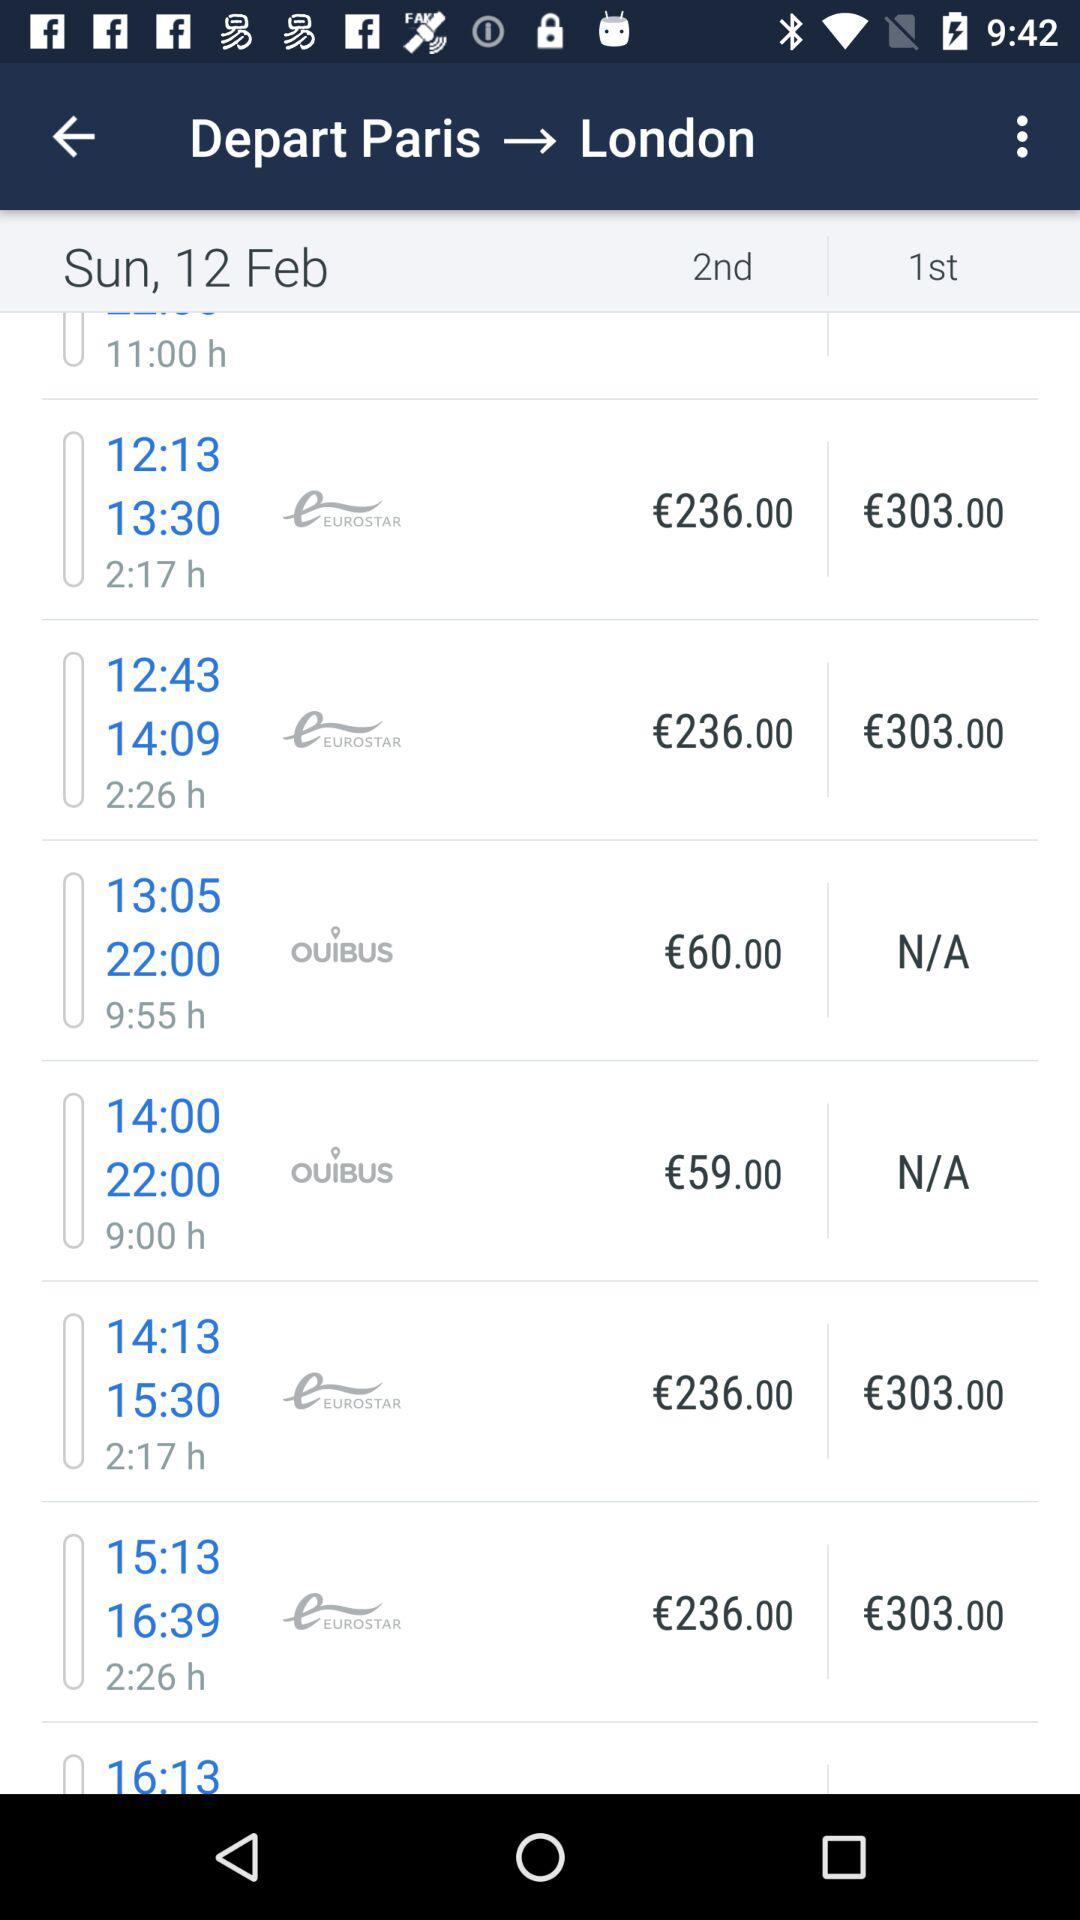How much more expensive is the first class ticket than the second class ticket?
Answer the question using a single word or phrase. €67.00 